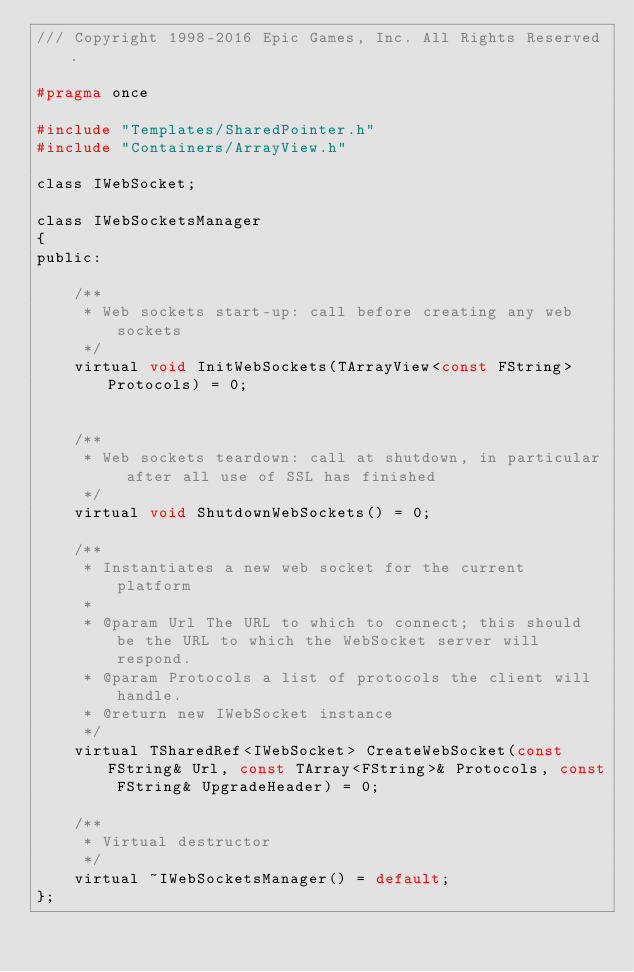Convert code to text. <code><loc_0><loc_0><loc_500><loc_500><_C_>/// Copyright 1998-2016 Epic Games, Inc. All Rights Reserved.

#pragma once

#include "Templates/SharedPointer.h"
#include "Containers/ArrayView.h"

class IWebSocket;

class IWebSocketsManager
{
public:

	/**
	 * Web sockets start-up: call before creating any web sockets
	 */ 
	virtual void InitWebSockets(TArrayView<const FString> Protocols) = 0;


	/**
	 * Web sockets teardown: call at shutdown, in particular after all use of SSL has finished
	 */ 
	virtual void ShutdownWebSockets() = 0;

	/**
	 * Instantiates a new web socket for the current platform
	 *
	 * @param Url The URL to which to connect; this should be the URL to which the WebSocket server will respond.
	 * @param Protocols a list of protocols the client will handle.
	 * @return new IWebSocket instance
	 */
	virtual TSharedRef<IWebSocket> CreateWebSocket(const FString& Url, const TArray<FString>& Protocols, const FString& UpgradeHeader) = 0;

	/**
	 * Virtual destructor
	 */
	virtual ~IWebSocketsManager() = default;
};
</code> 